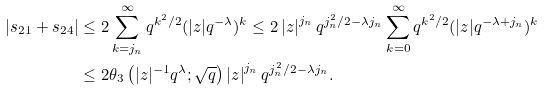Convert formula to latex. <formula><loc_0><loc_0><loc_500><loc_500>| s _ { 2 1 } + s _ { 2 4 } | & \leq 2 \sum _ { k = j _ { n } } ^ { \infty } q ^ { k ^ { 2 } / 2 } ( | z | q ^ { - \lambda } ) ^ { k } \leq 2 \left | z \right | ^ { j _ { n } } q ^ { j _ { n } ^ { 2 } / 2 - \lambda j _ { n } } \sum _ { k = 0 } ^ { \infty } q ^ { k ^ { 2 } / 2 } ( | z | q ^ { - \lambda + j _ { n } } ) ^ { k } \\ & \leq 2 \theta _ { 3 } \left ( | z | ^ { - 1 } q ^ { \lambda } ; \sqrt { q } \right ) \left | z \right | ^ { j _ { n } } q ^ { j _ { n } ^ { 2 } / 2 - \lambda j _ { n } } .</formula> 